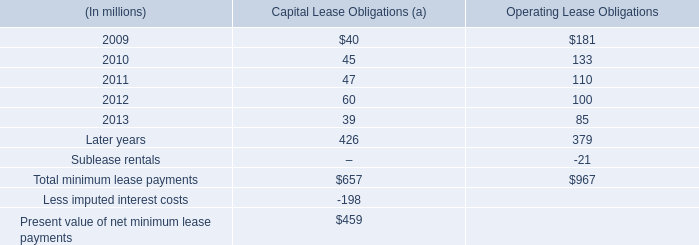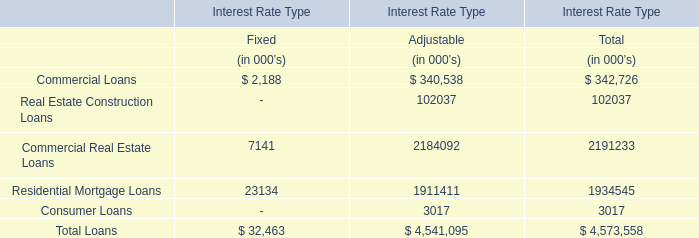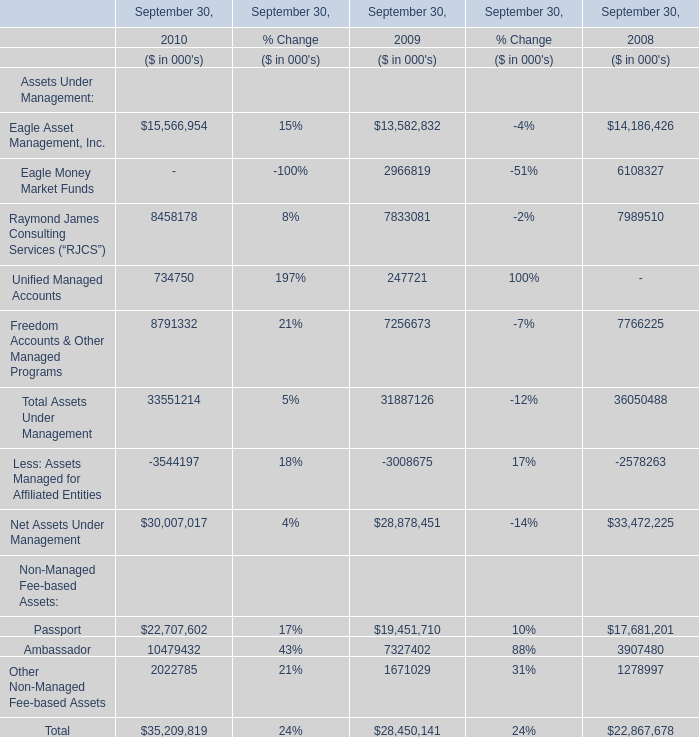What's the average of Assets Under Managemen in 2009? (in thousand) 
Computations: (28878451 / 7)
Answer: 4125493.0. 